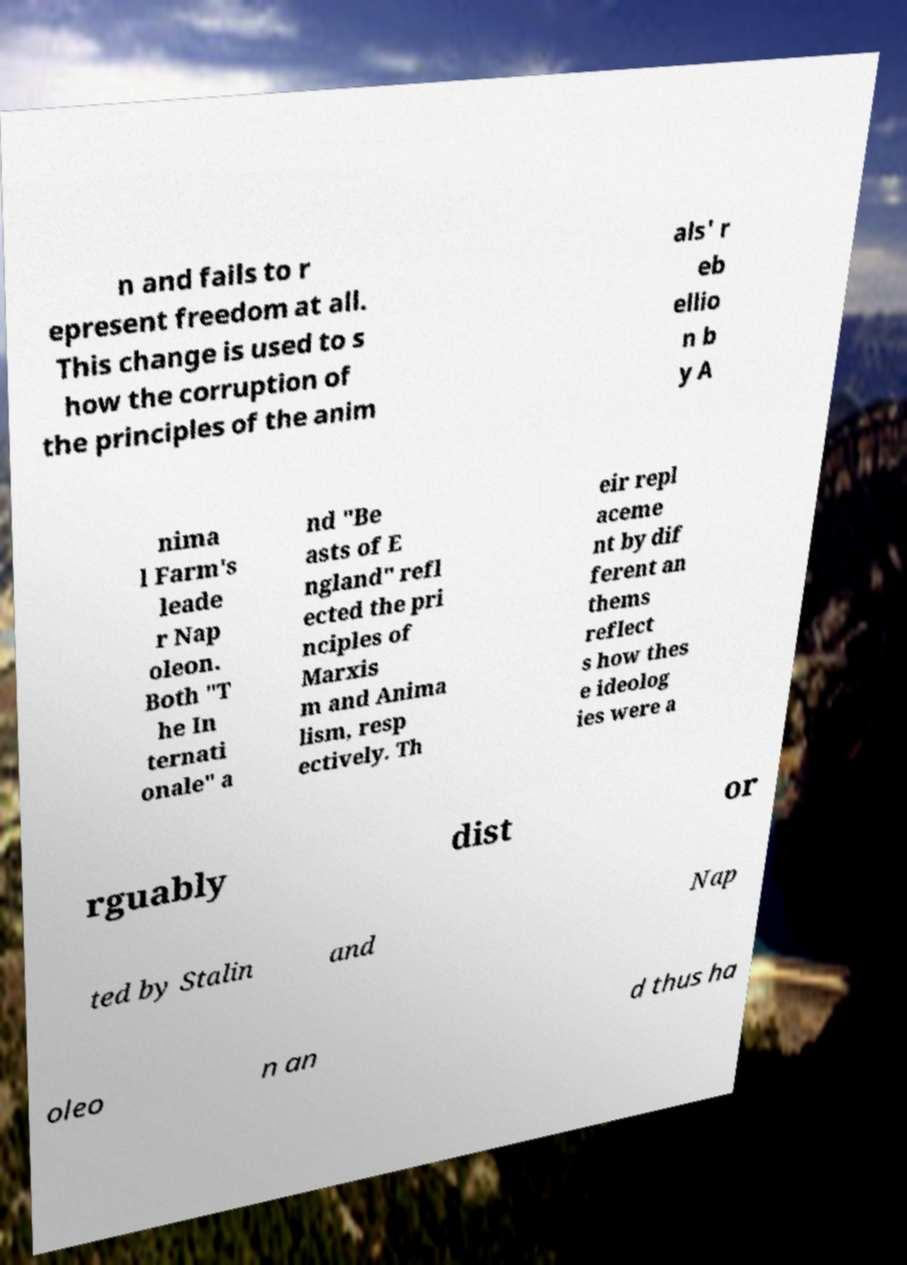Please read and relay the text visible in this image. What does it say? n and fails to r epresent freedom at all. This change is used to s how the corruption of the principles of the anim als' r eb ellio n b y A nima l Farm's leade r Nap oleon. Both "T he In ternati onale" a nd "Be asts of E ngland" refl ected the pri nciples of Marxis m and Anima lism, resp ectively. Th eir repl aceme nt by dif ferent an thems reflect s how thes e ideolog ies were a rguably dist or ted by Stalin and Nap oleo n an d thus ha 